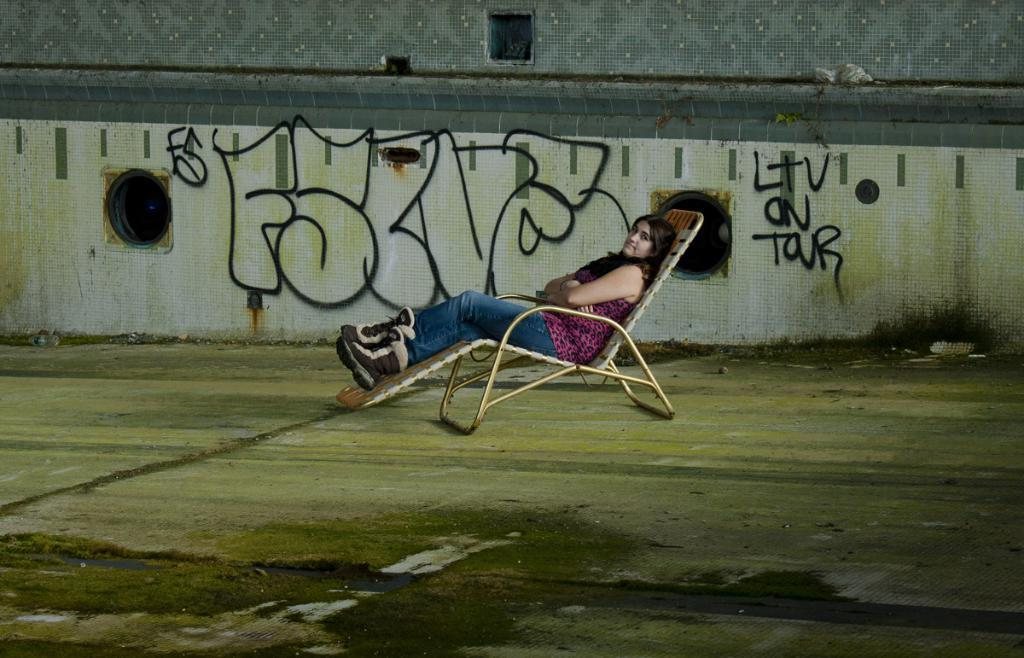What is present in the background of the image? There is a wall in the image. Can you describe the person in the image? There is a woman in the image. What is the woman doing in the image? The woman is sitting on a chair. What holiday is being celebrated in the image? There is no indication of a holiday being celebrated in the image. How many people are present in the image? The image only shows one person, a woman, is present. 